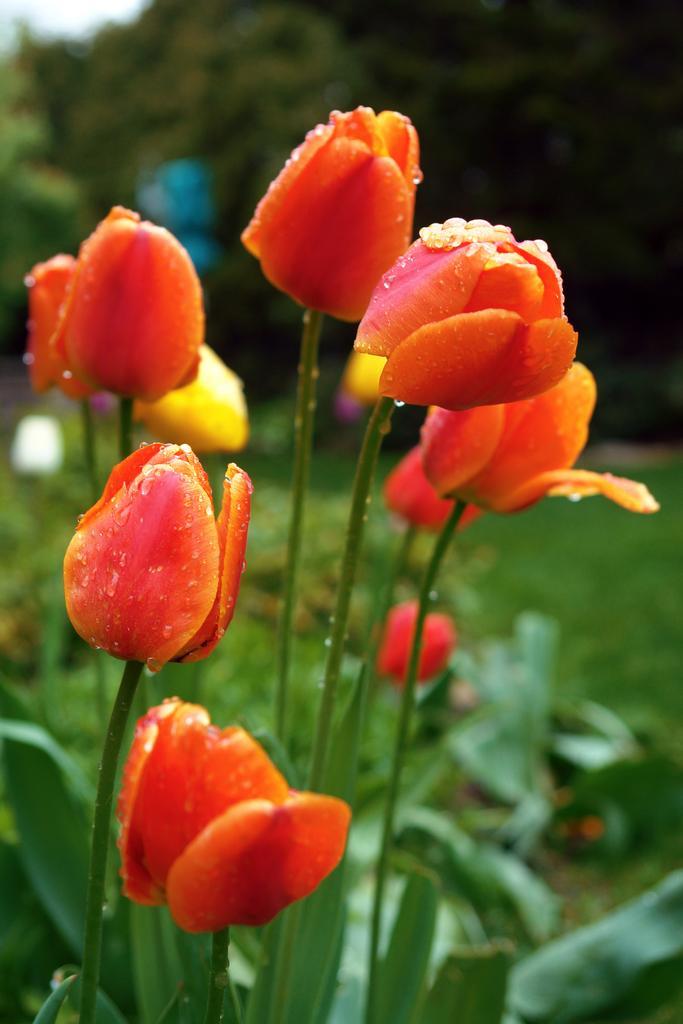Could you give a brief overview of what you see in this image? In this image we can see some flowers to the plants. On the backside we can see some trees. 